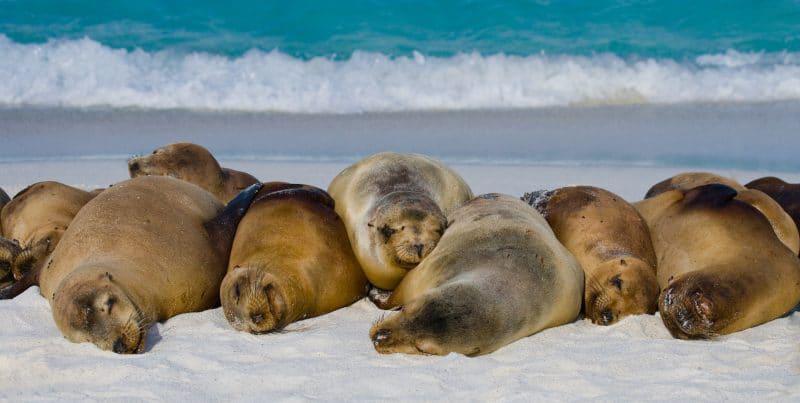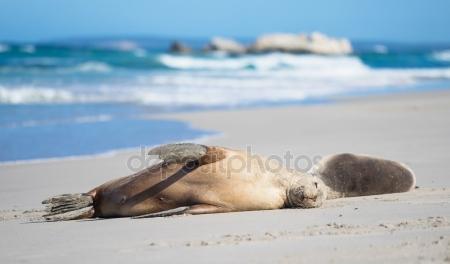The first image is the image on the left, the second image is the image on the right. Evaluate the accuracy of this statement regarding the images: "One image contains no more than two seals, who lie horizontally on the beach, and the other image shows seals lying lengthwise, head-first on the beach.". Is it true? Answer yes or no. Yes. The first image is the image on the left, the second image is the image on the right. Evaluate the accuracy of this statement regarding the images: "Two seals are lying in the sand in the image on the right.". Is it true? Answer yes or no. Yes. 